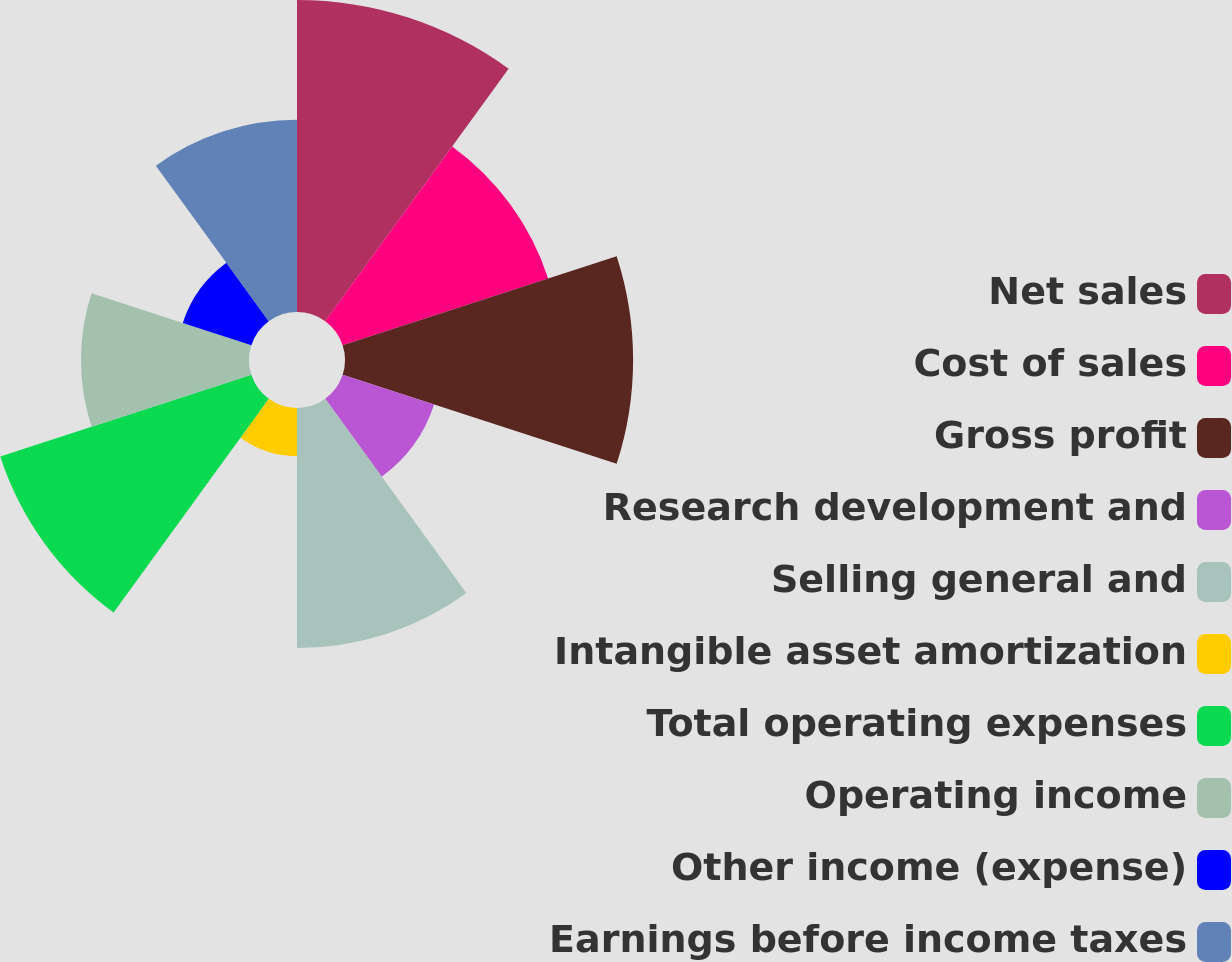Convert chart to OTSL. <chart><loc_0><loc_0><loc_500><loc_500><pie_chart><fcel>Net sales<fcel>Cost of sales<fcel>Gross profit<fcel>Research development and<fcel>Selling general and<fcel>Intangible asset amortization<fcel>Total operating expenses<fcel>Operating income<fcel>Other income (expense)<fcel>Earnings before income taxes<nl><fcel>16.45%<fcel>11.39%<fcel>15.19%<fcel>5.07%<fcel>12.66%<fcel>2.54%<fcel>13.92%<fcel>8.86%<fcel>3.8%<fcel>10.13%<nl></chart> 